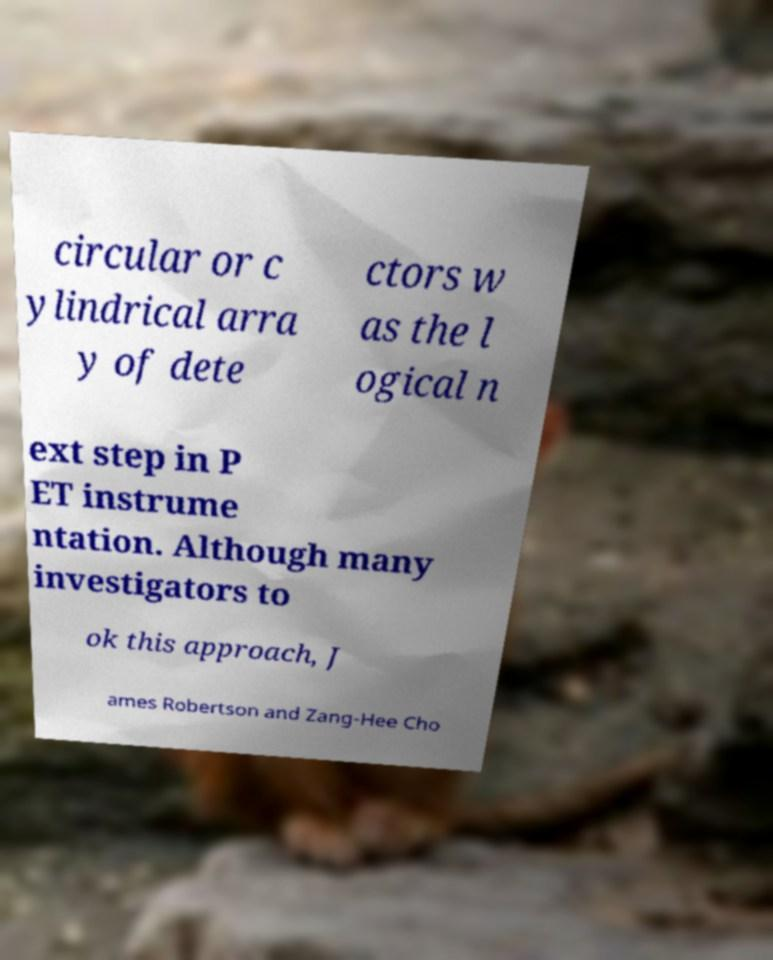I need the written content from this picture converted into text. Can you do that? circular or c ylindrical arra y of dete ctors w as the l ogical n ext step in P ET instrume ntation. Although many investigators to ok this approach, J ames Robertson and Zang-Hee Cho 